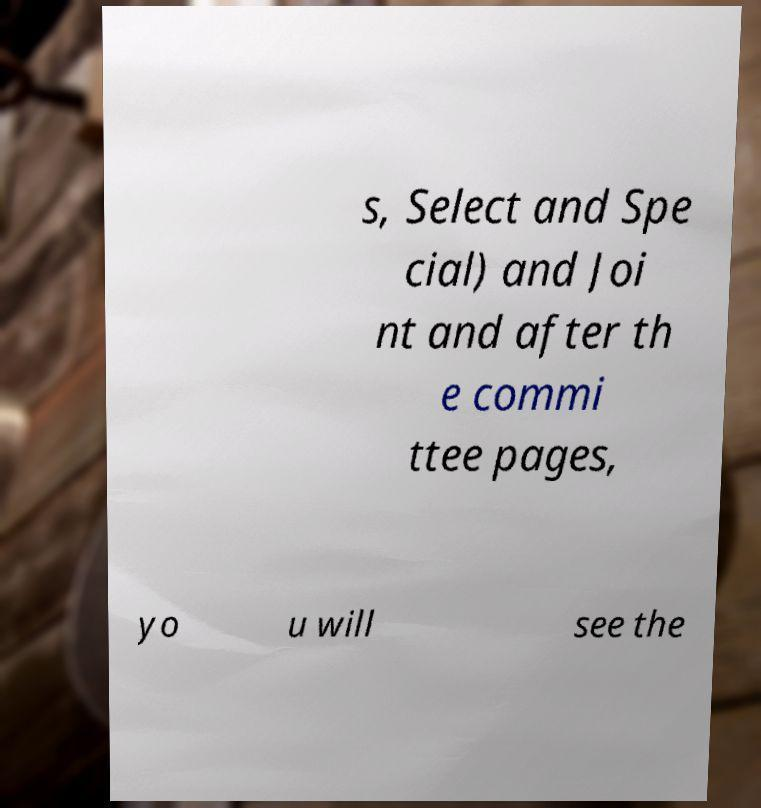Please identify and transcribe the text found in this image. s, Select and Spe cial) and Joi nt and after th e commi ttee pages, yo u will see the 